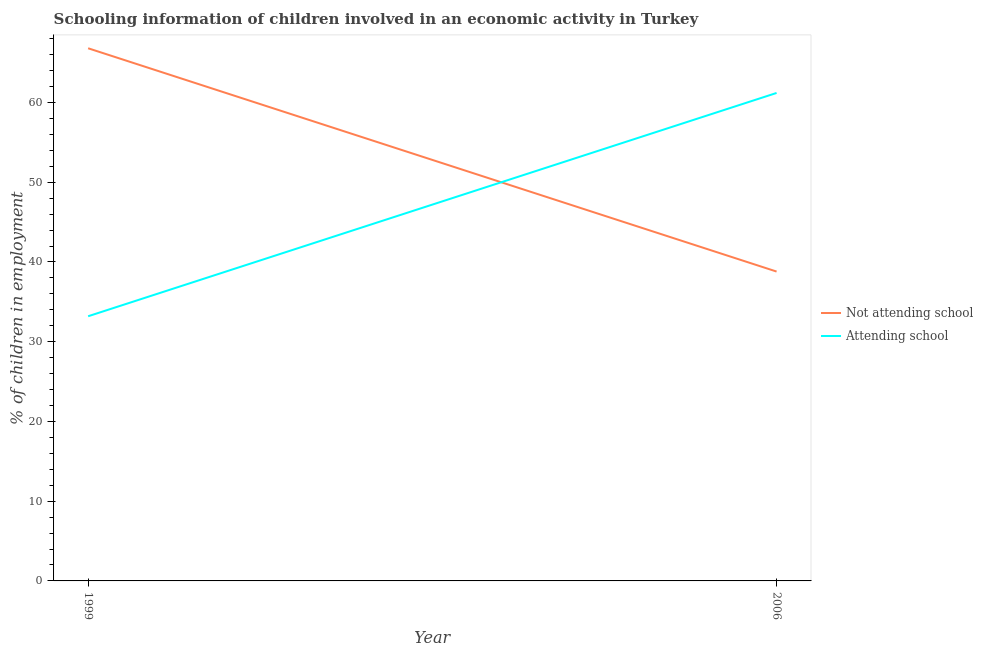Does the line corresponding to percentage of employed children who are not attending school intersect with the line corresponding to percentage of employed children who are attending school?
Give a very brief answer. Yes. What is the percentage of employed children who are not attending school in 1999?
Make the answer very short. 66.81. Across all years, what is the maximum percentage of employed children who are not attending school?
Your answer should be compact. 66.81. Across all years, what is the minimum percentage of employed children who are attending school?
Ensure brevity in your answer.  33.19. In which year was the percentage of employed children who are not attending school minimum?
Ensure brevity in your answer.  2006. What is the total percentage of employed children who are attending school in the graph?
Your answer should be compact. 94.39. What is the difference between the percentage of employed children who are attending school in 1999 and that in 2006?
Offer a terse response. -28.01. What is the difference between the percentage of employed children who are attending school in 2006 and the percentage of employed children who are not attending school in 1999?
Keep it short and to the point. -5.61. What is the average percentage of employed children who are attending school per year?
Offer a very short reply. 47.2. In the year 2006, what is the difference between the percentage of employed children who are attending school and percentage of employed children who are not attending school?
Give a very brief answer. 22.4. In how many years, is the percentage of employed children who are not attending school greater than 30 %?
Offer a very short reply. 2. What is the ratio of the percentage of employed children who are not attending school in 1999 to that in 2006?
Offer a very short reply. 1.72. Is the percentage of employed children who are attending school in 1999 less than that in 2006?
Your response must be concise. Yes. In how many years, is the percentage of employed children who are attending school greater than the average percentage of employed children who are attending school taken over all years?
Make the answer very short. 1. Is the percentage of employed children who are not attending school strictly greater than the percentage of employed children who are attending school over the years?
Make the answer very short. No. Are the values on the major ticks of Y-axis written in scientific E-notation?
Your response must be concise. No. Does the graph contain any zero values?
Offer a terse response. No. Does the graph contain grids?
Make the answer very short. No. How are the legend labels stacked?
Offer a terse response. Vertical. What is the title of the graph?
Offer a terse response. Schooling information of children involved in an economic activity in Turkey. What is the label or title of the X-axis?
Offer a very short reply. Year. What is the label or title of the Y-axis?
Give a very brief answer. % of children in employment. What is the % of children in employment of Not attending school in 1999?
Give a very brief answer. 66.81. What is the % of children in employment in Attending school in 1999?
Keep it short and to the point. 33.19. What is the % of children in employment of Not attending school in 2006?
Provide a short and direct response. 38.8. What is the % of children in employment of Attending school in 2006?
Provide a short and direct response. 61.2. Across all years, what is the maximum % of children in employment in Not attending school?
Your answer should be very brief. 66.81. Across all years, what is the maximum % of children in employment of Attending school?
Your response must be concise. 61.2. Across all years, what is the minimum % of children in employment of Not attending school?
Your answer should be very brief. 38.8. Across all years, what is the minimum % of children in employment in Attending school?
Make the answer very short. 33.19. What is the total % of children in employment in Not attending school in the graph?
Keep it short and to the point. 105.61. What is the total % of children in employment in Attending school in the graph?
Ensure brevity in your answer.  94.39. What is the difference between the % of children in employment in Not attending school in 1999 and that in 2006?
Give a very brief answer. 28. What is the difference between the % of children in employment of Attending school in 1999 and that in 2006?
Give a very brief answer. -28. What is the difference between the % of children in employment of Not attending school in 1999 and the % of children in employment of Attending school in 2006?
Provide a succinct answer. 5.61. What is the average % of children in employment of Not attending school per year?
Offer a terse response. 52.8. What is the average % of children in employment in Attending school per year?
Keep it short and to the point. 47.2. In the year 1999, what is the difference between the % of children in employment in Not attending school and % of children in employment in Attending school?
Offer a very short reply. 33.61. In the year 2006, what is the difference between the % of children in employment in Not attending school and % of children in employment in Attending school?
Your answer should be compact. -22.4. What is the ratio of the % of children in employment of Not attending school in 1999 to that in 2006?
Provide a succinct answer. 1.72. What is the ratio of the % of children in employment in Attending school in 1999 to that in 2006?
Provide a short and direct response. 0.54. What is the difference between the highest and the second highest % of children in employment of Not attending school?
Give a very brief answer. 28. What is the difference between the highest and the second highest % of children in employment of Attending school?
Your response must be concise. 28. What is the difference between the highest and the lowest % of children in employment of Not attending school?
Your answer should be compact. 28. What is the difference between the highest and the lowest % of children in employment of Attending school?
Ensure brevity in your answer.  28. 